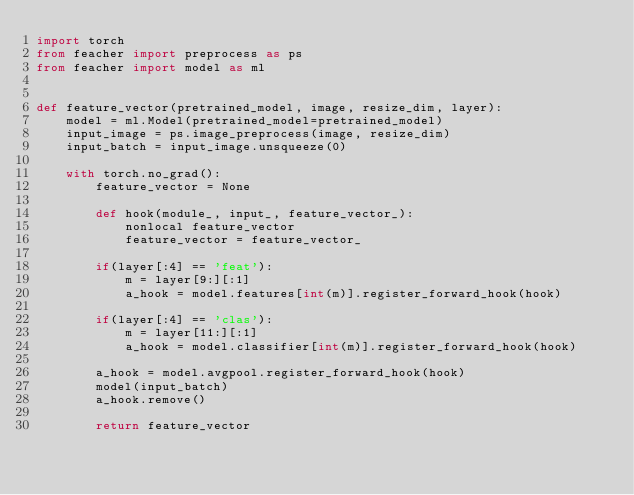Convert code to text. <code><loc_0><loc_0><loc_500><loc_500><_Python_>import torch
from feacher import preprocess as ps
from feacher import model as ml


def feature_vector(pretrained_model, image, resize_dim, layer):
    model = ml.Model(pretrained_model=pretrained_model)
    input_image = ps.image_preprocess(image, resize_dim)
    input_batch = input_image.unsqueeze(0)

    with torch.no_grad():
        feature_vector = None

        def hook(module_, input_, feature_vector_):
            nonlocal feature_vector
            feature_vector = feature_vector_

        if(layer[:4] == 'feat'):
            m = layer[9:][:1]
            a_hook = model.features[int(m)].register_forward_hook(hook)

        if(layer[:4] == 'clas'):
            m = layer[11:][:1]
            a_hook = model.classifier[int(m)].register_forward_hook(hook)

        a_hook = model.avgpool.register_forward_hook(hook)
        model(input_batch)
        a_hook.remove()

        return feature_vector
</code> 